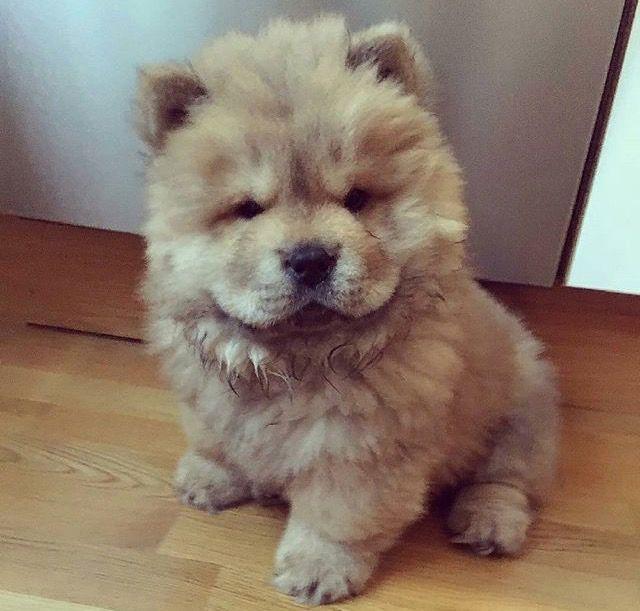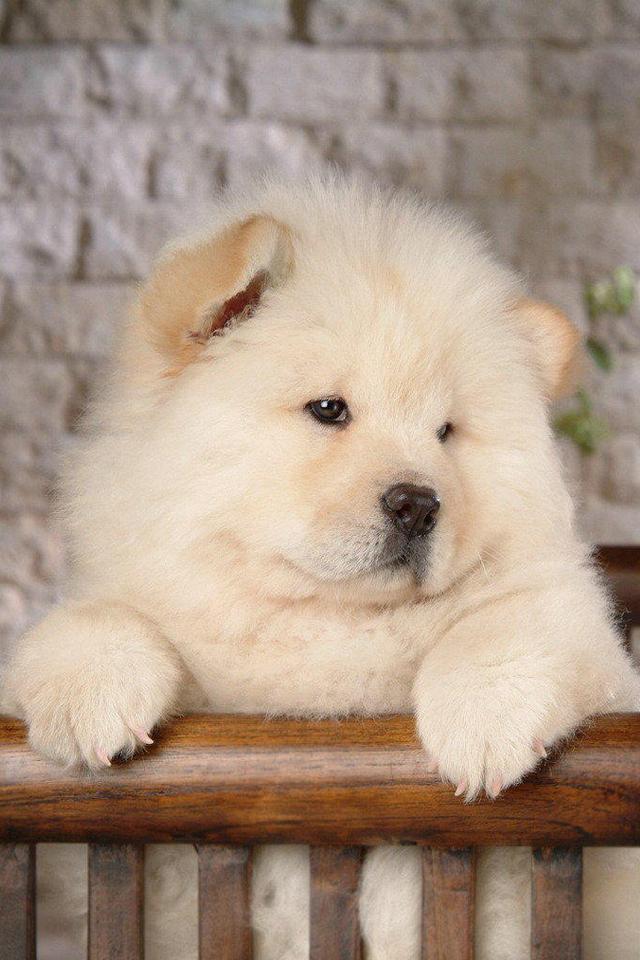The first image is the image on the left, the second image is the image on the right. Considering the images on both sides, is "There is one off white Chow Chow dog in both images." valid? Answer yes or no. Yes. The first image is the image on the left, the second image is the image on the right. For the images displayed, is the sentence "One chow is an adult dog with a flat forward-turned face and thick red orange mane, and no chows have blackish body fur." factually correct? Answer yes or no. No. 